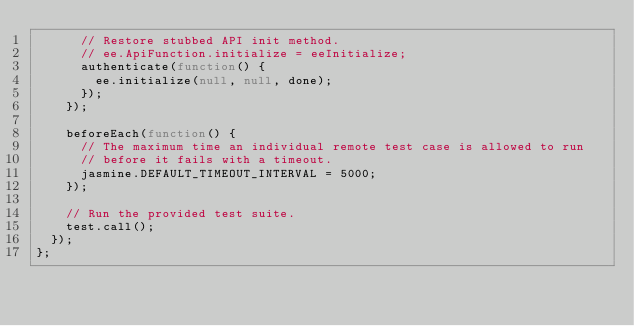Convert code to text. <code><loc_0><loc_0><loc_500><loc_500><_JavaScript_>      // Restore stubbed API init method.
      // ee.ApiFunction.initialize = eeInitialize;
      authenticate(function() {
        ee.initialize(null, null, done);
      });
    });

    beforeEach(function() {
      // The maximum time an individual remote test case is allowed to run
      // before it fails with a timeout.
      jasmine.DEFAULT_TIMEOUT_INTERVAL = 5000;
    });

    // Run the provided test suite.
    test.call();
  });
};
</code> 